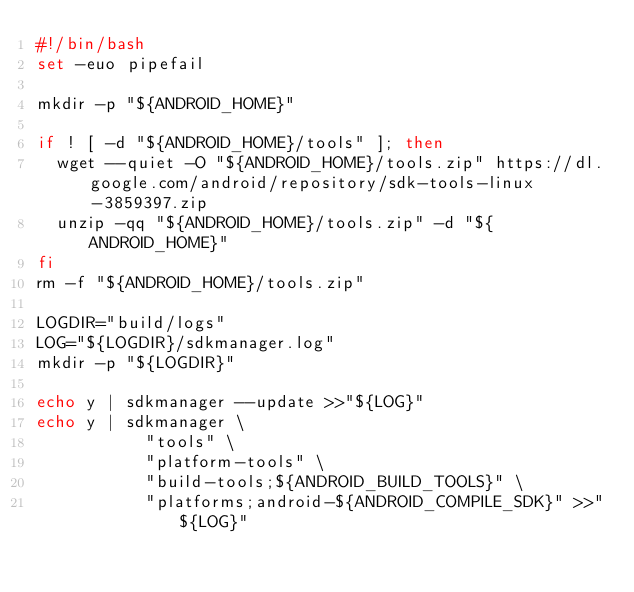Convert code to text. <code><loc_0><loc_0><loc_500><loc_500><_Bash_>#!/bin/bash
set -euo pipefail

mkdir -p "${ANDROID_HOME}"

if ! [ -d "${ANDROID_HOME}/tools" ]; then
  wget --quiet -O "${ANDROID_HOME}/tools.zip" https://dl.google.com/android/repository/sdk-tools-linux-3859397.zip
  unzip -qq "${ANDROID_HOME}/tools.zip" -d "${ANDROID_HOME}"
fi
rm -f "${ANDROID_HOME}/tools.zip"

LOGDIR="build/logs"
LOG="${LOGDIR}/sdkmanager.log"
mkdir -p "${LOGDIR}"

echo y | sdkmanager --update >>"${LOG}"
echo y | sdkmanager \
           "tools" \
           "platform-tools" \
           "build-tools;${ANDROID_BUILD_TOOLS}" \
           "platforms;android-${ANDROID_COMPILE_SDK}" >>"${LOG}"
</code> 